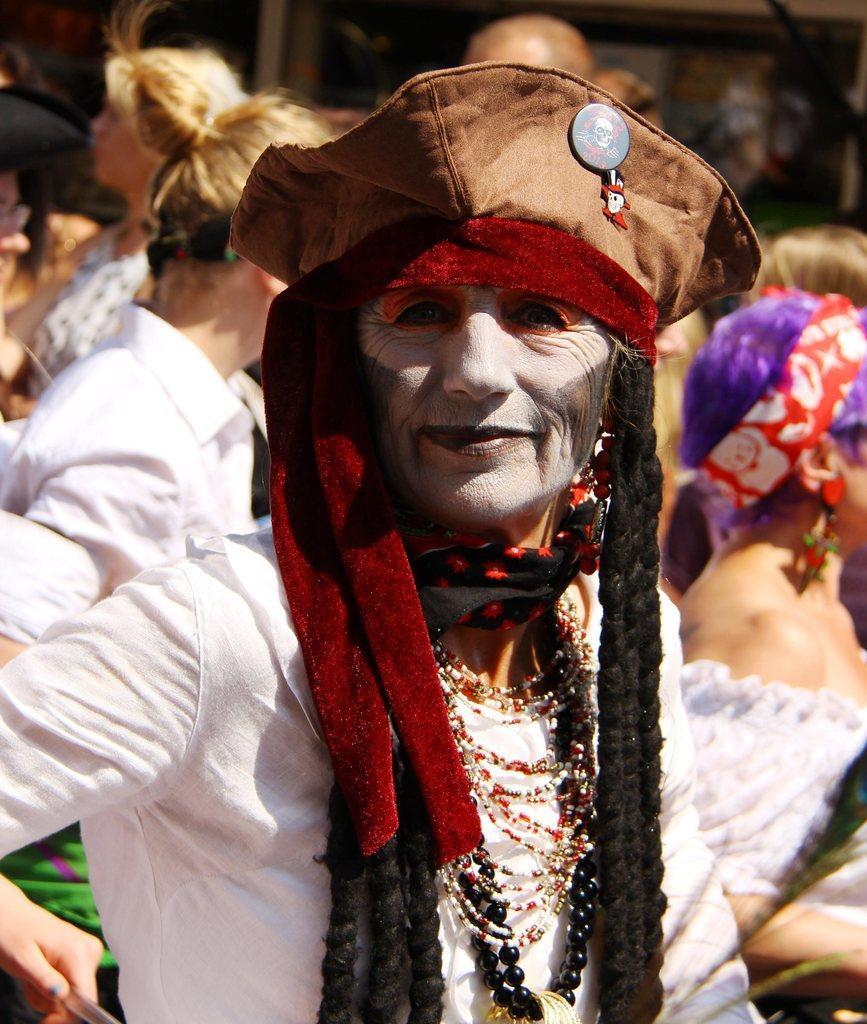Could you give a brief overview of what you see in this image? In this image we can see some group of persons wearing different costumes and standing. 